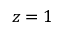Convert formula to latex. <formula><loc_0><loc_0><loc_500><loc_500>z = 1</formula> 